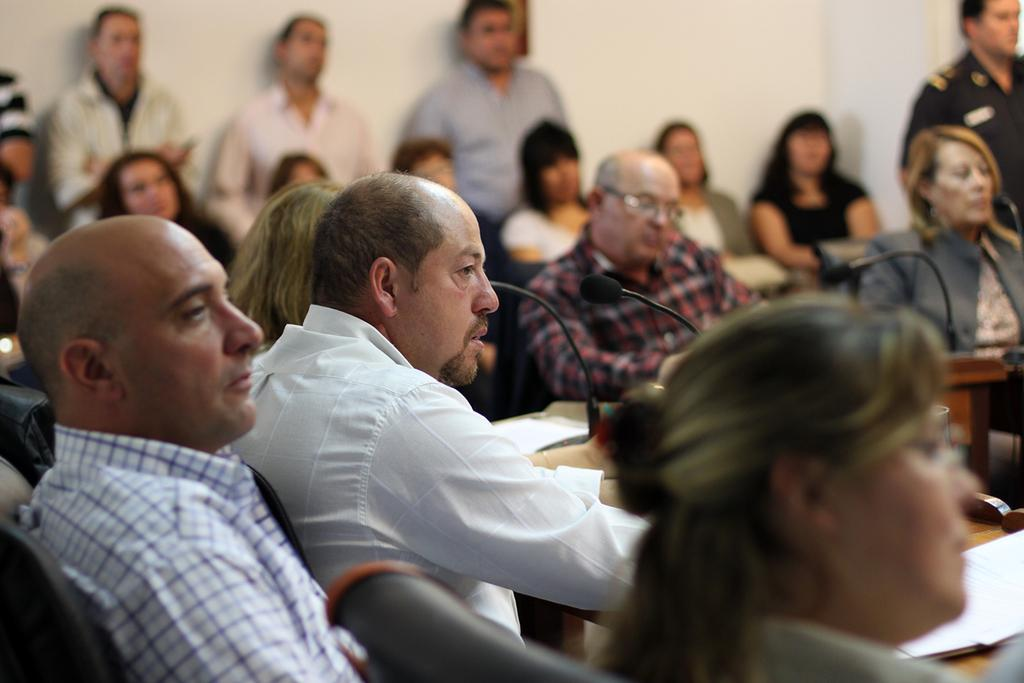What are the people in the image doing? There are people sitting on chairs and standing in the image. What objects can be seen in the image that are used for amplifying sound? Microphones are present in the image. What items can be found on the tables in the image? Papers are on tables in the image. What is visible in the background of the image? There is a wall in the background of the image. What type of bait is being used to catch fish in the image? There is no mention of fish or bait in the image; it features people, chairs, microphones, papers, and a wall in the background. 